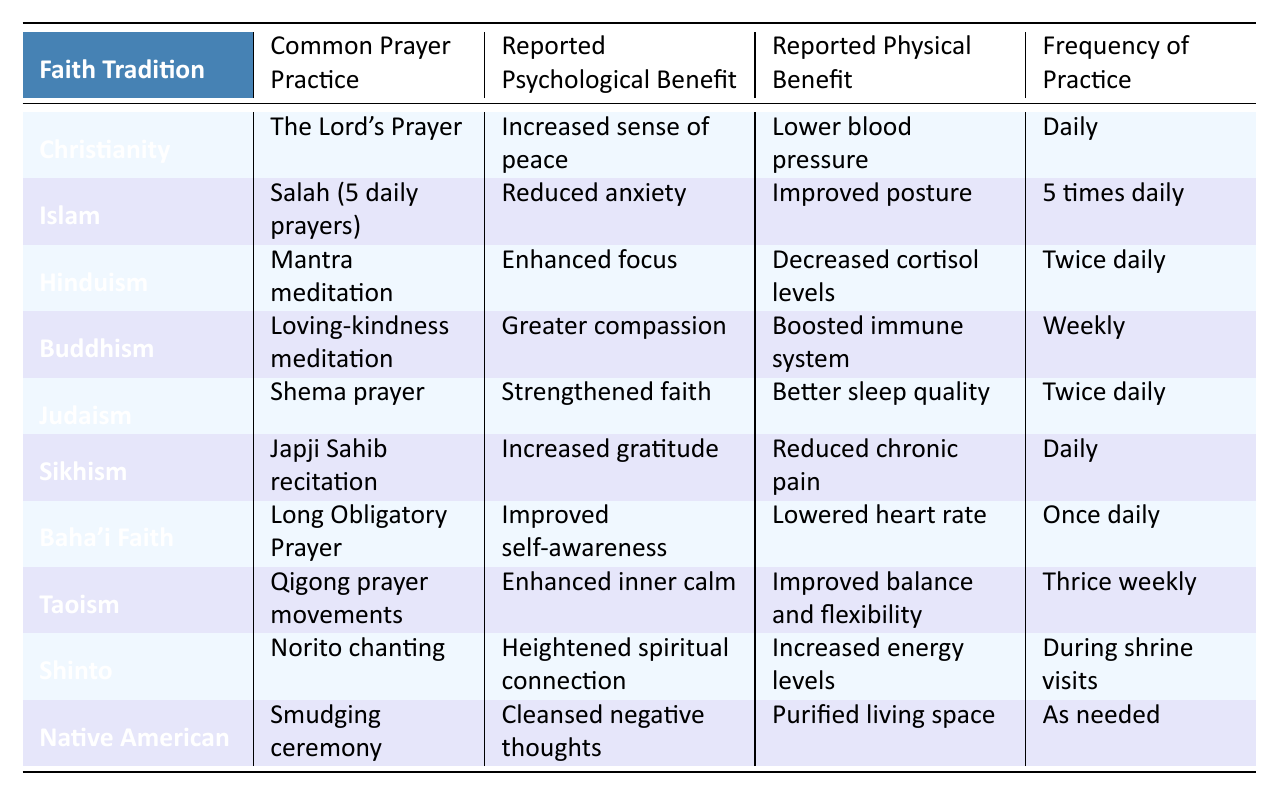What is the common prayer practice in Islam? The table lists the common prayer practice for Islam as "Salah (5 daily prayers)."
Answer: Salah (5 daily prayers) Which faith tradition reports "Enhanced focus" as a psychological benefit? Looking at the table, Hinduism is the faith tradition associated with "Enhanced focus."
Answer: Hinduism How many times daily do Sikhs practice their prayer? The table indicates that Sikhs practice their prayer daily, which means once each day.
Answer: Daily What are the reported physical benefits of the Baha'i Faith's prayer practice? According to the table, the reported physical benefit of the Baha'i Faith's Long Obligatory Prayer is "Lowered heart rate."
Answer: Lowered heart rate Is there a faith tradition that practices prayer only as needed? Yes, the Native American tradition practices prayer as needed, as indicated in the table.
Answer: Yes What is the frequency of the loving-kindness meditation in Buddhism? The table shows that loving-kindness meditation in Buddhism is practiced weekly.
Answer: Weekly Which faith tradition has the highest frequency of prayer practices? By comparing the frequencies, Islam has the highest frequency with "5 times daily."
Answer: Islam What psychological benefit is reported by both Sikhism and Judaism? The table shows that both Sikhism and Judaism report "Increased gratitude" and "Strengthened faith," respectively, but they do not share the same benefit. Therefore, there is none.
Answer: None Calculate the total number of prayer practices that occur daily across the faiths represented in the table. From the table, Christianity, Sikhism, and Baha'i Faith practice prayer daily. This gives a total of 3 daily practices.
Answer: 3 Which prayer practice has the reported benefit of "Boosted immune system"? The table states that the "Loving-kindness meditation" in Buddhism has the reported benefit of "Boosted immune system."
Answer: Loving-kindness meditation Do any of the prayer practices have a reported benefit related to sleep quality? Yes, the Shema prayer in Judaism is noted for having the reported benefit of "Better sleep quality."
Answer: Yes 